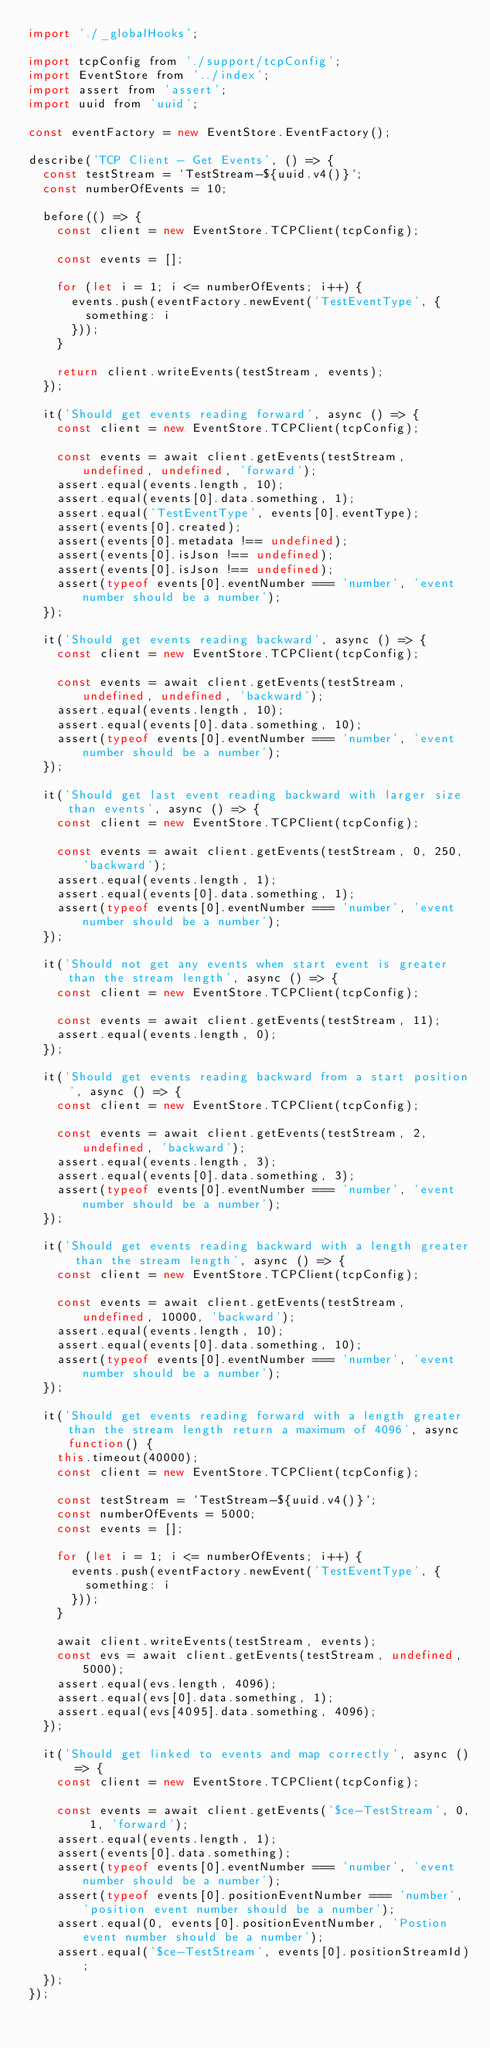Convert code to text. <code><loc_0><loc_0><loc_500><loc_500><_JavaScript_>import './_globalHooks';

import tcpConfig from './support/tcpConfig';
import EventStore from '../index';
import assert from 'assert';
import uuid from 'uuid';

const eventFactory = new EventStore.EventFactory();

describe('TCP Client - Get Events', () => {
	const testStream = `TestStream-${uuid.v4()}`;
	const numberOfEvents = 10;

	before(() => {
		const client = new EventStore.TCPClient(tcpConfig);

		const events = [];

		for (let i = 1; i <= numberOfEvents; i++) {
			events.push(eventFactory.newEvent('TestEventType', {
				something: i
			}));
		}

		return client.writeEvents(testStream, events);
	});

	it('Should get events reading forward', async () => {
		const client = new EventStore.TCPClient(tcpConfig);

		const events = await client.getEvents(testStream, undefined, undefined, 'forward');
		assert.equal(events.length, 10);
		assert.equal(events[0].data.something, 1);
		assert.equal('TestEventType', events[0].eventType);
		assert(events[0].created);
		assert(events[0].metadata !== undefined);
		assert(events[0].isJson !== undefined);
		assert(events[0].isJson !== undefined);
		assert(typeof events[0].eventNumber === 'number', 'event number should be a number');
	});

	it('Should get events reading backward', async () => {
		const client = new EventStore.TCPClient(tcpConfig);

		const events = await client.getEvents(testStream, undefined, undefined, 'backward');
		assert.equal(events.length, 10);
		assert.equal(events[0].data.something, 10);
		assert(typeof events[0].eventNumber === 'number', 'event number should be a number');
	});

	it('Should get last event reading backward with larger size than events', async () => {
		const client = new EventStore.TCPClient(tcpConfig);

		const events = await client.getEvents(testStream, 0, 250, 'backward');
		assert.equal(events.length, 1);
		assert.equal(events[0].data.something, 1);
		assert(typeof events[0].eventNumber === 'number', 'event number should be a number');
	});

	it('Should not get any events when start event is greater than the stream length', async () => {
		const client = new EventStore.TCPClient(tcpConfig);

		const events = await client.getEvents(testStream, 11);
		assert.equal(events.length, 0);
	});

	it('Should get events reading backward from a start position', async () => {
		const client = new EventStore.TCPClient(tcpConfig);

		const events = await client.getEvents(testStream, 2, undefined, 'backward');
		assert.equal(events.length, 3);
		assert.equal(events[0].data.something, 3);
		assert(typeof events[0].eventNumber === 'number', 'event number should be a number');
	});

	it('Should get events reading backward with a length greater than the stream length', async () => {
		const client = new EventStore.TCPClient(tcpConfig);

		const events = await client.getEvents(testStream, undefined, 10000, 'backward');
		assert.equal(events.length, 10);
		assert.equal(events[0].data.something, 10);
		assert(typeof events[0].eventNumber === 'number', 'event number should be a number');
	});

	it('Should get events reading forward with a length greater than the stream length return a maximum of 4096', async function() {
		this.timeout(40000);
		const client = new EventStore.TCPClient(tcpConfig);

		const testStream = `TestStream-${uuid.v4()}`;
		const numberOfEvents = 5000;
		const events = [];

		for (let i = 1; i <= numberOfEvents; i++) {
			events.push(eventFactory.newEvent('TestEventType', {
				something: i
			}));
		}

		await client.writeEvents(testStream, events);
		const evs = await client.getEvents(testStream, undefined, 5000);
		assert.equal(evs.length, 4096);
		assert.equal(evs[0].data.something, 1);
		assert.equal(evs[4095].data.something, 4096);
	});

	it('Should get linked to events and map correctly', async () => {
		const client = new EventStore.TCPClient(tcpConfig);

		const events = await client.getEvents('$ce-TestStream', 0, 1, 'forward');
		assert.equal(events.length, 1);
		assert(events[0].data.something);
		assert(typeof events[0].eventNumber === 'number', 'event number should be a number');
		assert(typeof events[0].positionEventNumber === 'number', 'position event number should be a number');
		assert.equal(0, events[0].positionEventNumber, 'Postion event number should be a number');
		assert.equal('$ce-TestStream', events[0].positionStreamId);
	});
});</code> 